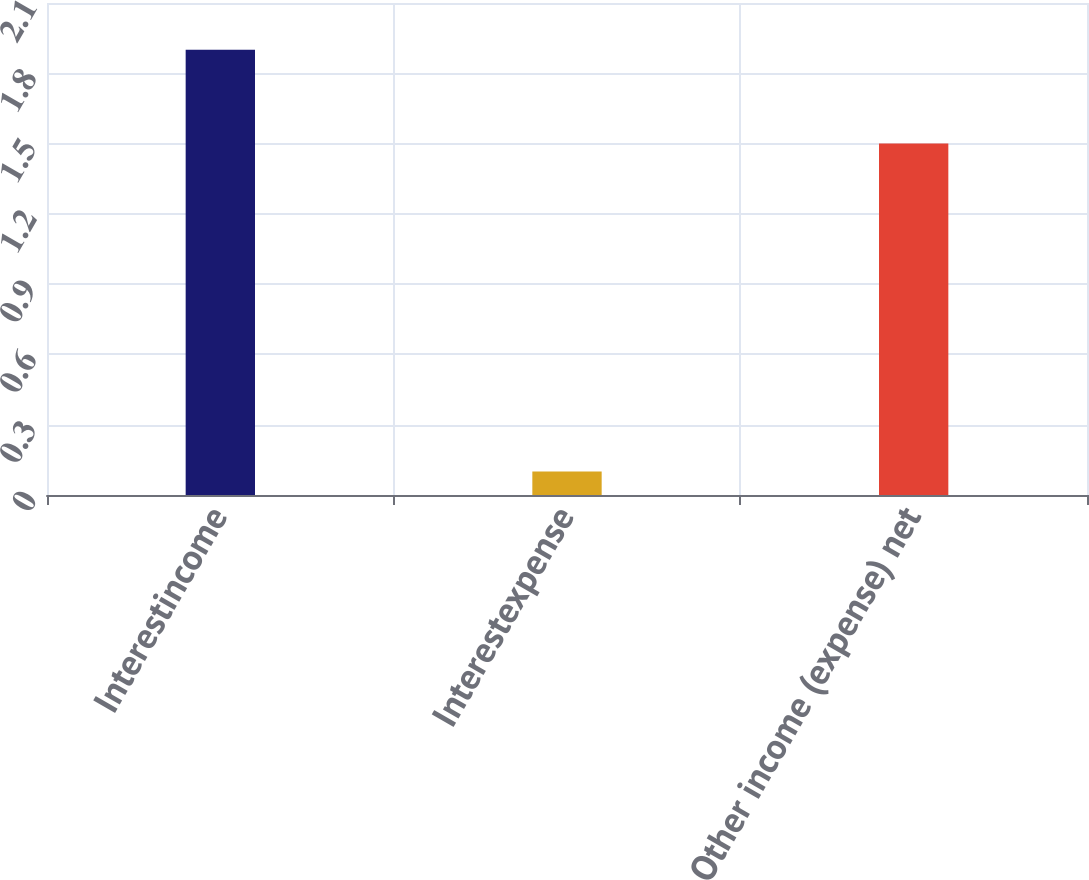Convert chart to OTSL. <chart><loc_0><loc_0><loc_500><loc_500><bar_chart><fcel>Interestincome<fcel>Interestexpense<fcel>Other income (expense) net<nl><fcel>1.9<fcel>0.1<fcel>1.5<nl></chart> 